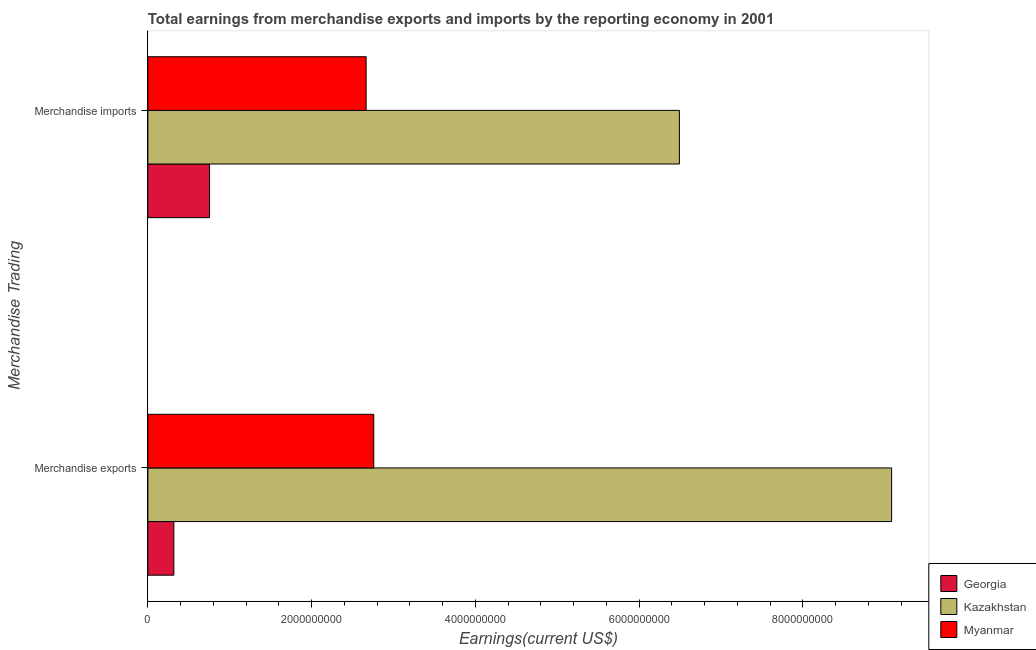How many different coloured bars are there?
Ensure brevity in your answer.  3. How many groups of bars are there?
Provide a short and direct response. 2. Are the number of bars per tick equal to the number of legend labels?
Your response must be concise. Yes. Are the number of bars on each tick of the Y-axis equal?
Provide a succinct answer. Yes. How many bars are there on the 2nd tick from the top?
Offer a terse response. 3. How many bars are there on the 1st tick from the bottom?
Provide a short and direct response. 3. What is the earnings from merchandise imports in Myanmar?
Ensure brevity in your answer.  2.67e+09. Across all countries, what is the maximum earnings from merchandise exports?
Make the answer very short. 9.09e+09. Across all countries, what is the minimum earnings from merchandise exports?
Your response must be concise. 3.17e+08. In which country was the earnings from merchandise exports maximum?
Your answer should be compact. Kazakhstan. In which country was the earnings from merchandise exports minimum?
Offer a very short reply. Georgia. What is the total earnings from merchandise exports in the graph?
Offer a terse response. 1.22e+1. What is the difference between the earnings from merchandise imports in Georgia and that in Myanmar?
Offer a terse response. -1.91e+09. What is the difference between the earnings from merchandise exports in Kazakhstan and the earnings from merchandise imports in Myanmar?
Your answer should be very brief. 6.42e+09. What is the average earnings from merchandise imports per country?
Keep it short and to the point. 3.30e+09. What is the difference between the earnings from merchandise exports and earnings from merchandise imports in Myanmar?
Make the answer very short. 9.34e+07. In how many countries, is the earnings from merchandise imports greater than 6000000000 US$?
Your answer should be compact. 1. What is the ratio of the earnings from merchandise exports in Kazakhstan to that in Myanmar?
Your response must be concise. 3.29. Is the earnings from merchandise exports in Kazakhstan less than that in Myanmar?
Ensure brevity in your answer.  No. What does the 3rd bar from the top in Merchandise exports represents?
Provide a short and direct response. Georgia. What does the 3rd bar from the bottom in Merchandise imports represents?
Your answer should be very brief. Myanmar. Are all the bars in the graph horizontal?
Your answer should be compact. Yes. How many countries are there in the graph?
Provide a short and direct response. 3. Does the graph contain any zero values?
Provide a succinct answer. No. How are the legend labels stacked?
Keep it short and to the point. Vertical. What is the title of the graph?
Your answer should be very brief. Total earnings from merchandise exports and imports by the reporting economy in 2001. What is the label or title of the X-axis?
Your answer should be very brief. Earnings(current US$). What is the label or title of the Y-axis?
Ensure brevity in your answer.  Merchandise Trading. What is the Earnings(current US$) of Georgia in Merchandise exports?
Your answer should be very brief. 3.17e+08. What is the Earnings(current US$) in Kazakhstan in Merchandise exports?
Make the answer very short. 9.09e+09. What is the Earnings(current US$) in Myanmar in Merchandise exports?
Ensure brevity in your answer.  2.76e+09. What is the Earnings(current US$) in Georgia in Merchandise imports?
Your response must be concise. 7.54e+08. What is the Earnings(current US$) of Kazakhstan in Merchandise imports?
Ensure brevity in your answer.  6.49e+09. What is the Earnings(current US$) in Myanmar in Merchandise imports?
Your answer should be compact. 2.67e+09. Across all Merchandise Trading, what is the maximum Earnings(current US$) in Georgia?
Provide a succinct answer. 7.54e+08. Across all Merchandise Trading, what is the maximum Earnings(current US$) in Kazakhstan?
Your answer should be very brief. 9.09e+09. Across all Merchandise Trading, what is the maximum Earnings(current US$) in Myanmar?
Your answer should be very brief. 2.76e+09. Across all Merchandise Trading, what is the minimum Earnings(current US$) of Georgia?
Give a very brief answer. 3.17e+08. Across all Merchandise Trading, what is the minimum Earnings(current US$) of Kazakhstan?
Offer a terse response. 6.49e+09. Across all Merchandise Trading, what is the minimum Earnings(current US$) in Myanmar?
Your answer should be very brief. 2.67e+09. What is the total Earnings(current US$) in Georgia in the graph?
Ensure brevity in your answer.  1.07e+09. What is the total Earnings(current US$) in Kazakhstan in the graph?
Provide a succinct answer. 1.56e+1. What is the total Earnings(current US$) of Myanmar in the graph?
Your answer should be compact. 5.43e+09. What is the difference between the Earnings(current US$) of Georgia in Merchandise exports and that in Merchandise imports?
Provide a succinct answer. -4.36e+08. What is the difference between the Earnings(current US$) in Kazakhstan in Merchandise exports and that in Merchandise imports?
Offer a very short reply. 2.59e+09. What is the difference between the Earnings(current US$) in Myanmar in Merchandise exports and that in Merchandise imports?
Provide a short and direct response. 9.34e+07. What is the difference between the Earnings(current US$) in Georgia in Merchandise exports and the Earnings(current US$) in Kazakhstan in Merchandise imports?
Offer a very short reply. -6.18e+09. What is the difference between the Earnings(current US$) of Georgia in Merchandise exports and the Earnings(current US$) of Myanmar in Merchandise imports?
Provide a short and direct response. -2.35e+09. What is the difference between the Earnings(current US$) in Kazakhstan in Merchandise exports and the Earnings(current US$) in Myanmar in Merchandise imports?
Provide a short and direct response. 6.42e+09. What is the average Earnings(current US$) of Georgia per Merchandise Trading?
Offer a very short reply. 5.35e+08. What is the average Earnings(current US$) of Kazakhstan per Merchandise Trading?
Provide a short and direct response. 7.79e+09. What is the average Earnings(current US$) of Myanmar per Merchandise Trading?
Your response must be concise. 2.71e+09. What is the difference between the Earnings(current US$) in Georgia and Earnings(current US$) in Kazakhstan in Merchandise exports?
Offer a terse response. -8.77e+09. What is the difference between the Earnings(current US$) in Georgia and Earnings(current US$) in Myanmar in Merchandise exports?
Provide a short and direct response. -2.44e+09. What is the difference between the Earnings(current US$) of Kazakhstan and Earnings(current US$) of Myanmar in Merchandise exports?
Your response must be concise. 6.33e+09. What is the difference between the Earnings(current US$) in Georgia and Earnings(current US$) in Kazakhstan in Merchandise imports?
Ensure brevity in your answer.  -5.74e+09. What is the difference between the Earnings(current US$) of Georgia and Earnings(current US$) of Myanmar in Merchandise imports?
Provide a succinct answer. -1.91e+09. What is the difference between the Earnings(current US$) of Kazakhstan and Earnings(current US$) of Myanmar in Merchandise imports?
Keep it short and to the point. 3.83e+09. What is the ratio of the Earnings(current US$) in Georgia in Merchandise exports to that in Merchandise imports?
Offer a very short reply. 0.42. What is the ratio of the Earnings(current US$) in Kazakhstan in Merchandise exports to that in Merchandise imports?
Ensure brevity in your answer.  1.4. What is the ratio of the Earnings(current US$) in Myanmar in Merchandise exports to that in Merchandise imports?
Offer a very short reply. 1.03. What is the difference between the highest and the second highest Earnings(current US$) of Georgia?
Offer a very short reply. 4.36e+08. What is the difference between the highest and the second highest Earnings(current US$) of Kazakhstan?
Offer a very short reply. 2.59e+09. What is the difference between the highest and the second highest Earnings(current US$) of Myanmar?
Ensure brevity in your answer.  9.34e+07. What is the difference between the highest and the lowest Earnings(current US$) of Georgia?
Provide a succinct answer. 4.36e+08. What is the difference between the highest and the lowest Earnings(current US$) of Kazakhstan?
Make the answer very short. 2.59e+09. What is the difference between the highest and the lowest Earnings(current US$) in Myanmar?
Offer a very short reply. 9.34e+07. 